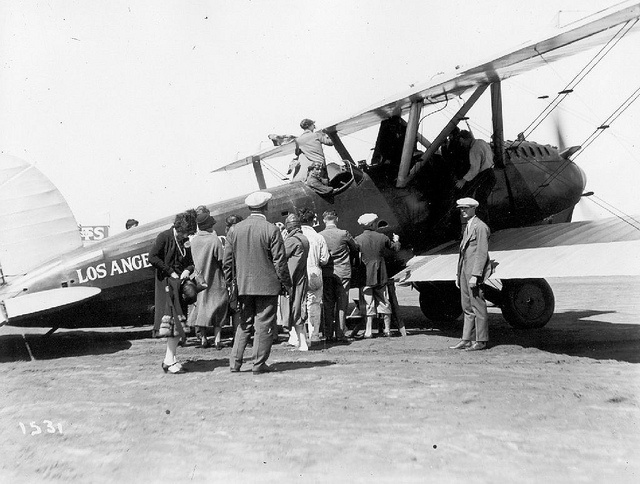Describe the objects in this image and their specific colors. I can see airplane in white, black, lightgray, gray, and darkgray tones, people in white, gray, darkgray, black, and lightgray tones, people in white, black, gray, darkgray, and lightgray tones, people in white, darkgray, gray, black, and lightgray tones, and people in white, black, gray, darkgray, and lightgray tones in this image. 